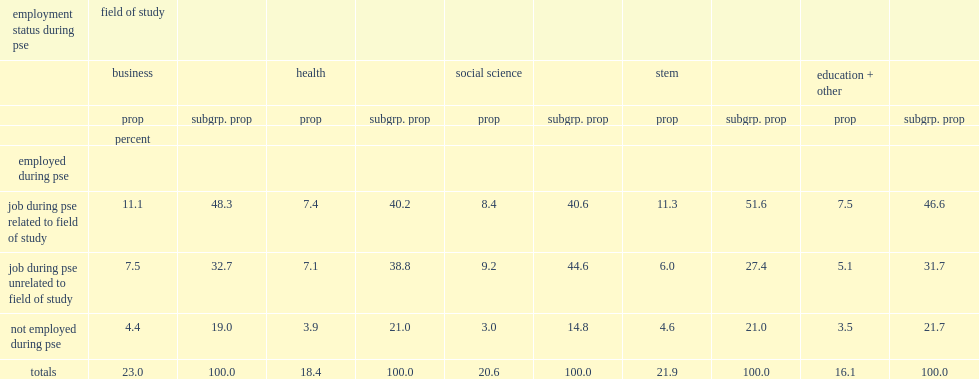What was the percentage of four areas accounting for all graduates? 83.9. 